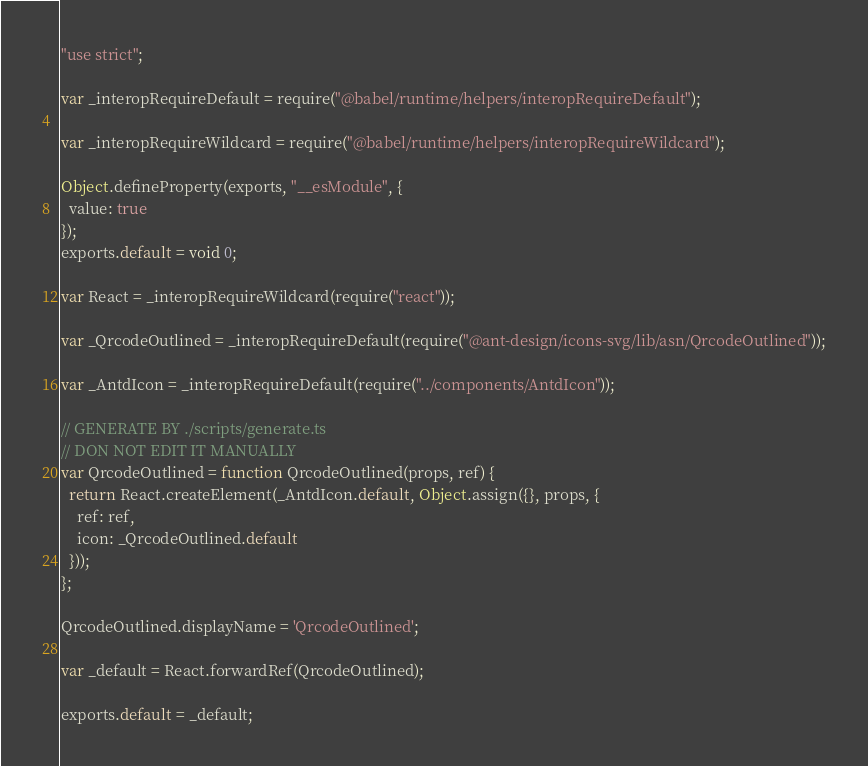Convert code to text. <code><loc_0><loc_0><loc_500><loc_500><_JavaScript_>"use strict";

var _interopRequireDefault = require("@babel/runtime/helpers/interopRequireDefault");

var _interopRequireWildcard = require("@babel/runtime/helpers/interopRequireWildcard");

Object.defineProperty(exports, "__esModule", {
  value: true
});
exports.default = void 0;

var React = _interopRequireWildcard(require("react"));

var _QrcodeOutlined = _interopRequireDefault(require("@ant-design/icons-svg/lib/asn/QrcodeOutlined"));

var _AntdIcon = _interopRequireDefault(require("../components/AntdIcon"));

// GENERATE BY ./scripts/generate.ts
// DON NOT EDIT IT MANUALLY
var QrcodeOutlined = function QrcodeOutlined(props, ref) {
  return React.createElement(_AntdIcon.default, Object.assign({}, props, {
    ref: ref,
    icon: _QrcodeOutlined.default
  }));
};

QrcodeOutlined.displayName = 'QrcodeOutlined';

var _default = React.forwardRef(QrcodeOutlined);

exports.default = _default;</code> 